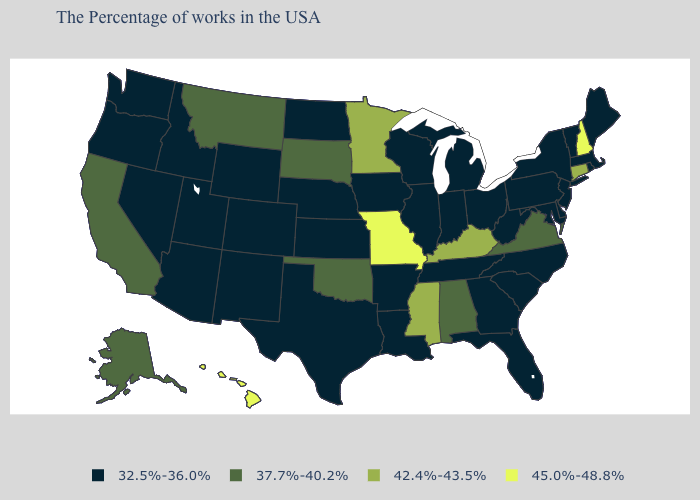What is the highest value in the USA?
Be succinct. 45.0%-48.8%. Name the states that have a value in the range 42.4%-43.5%?
Give a very brief answer. Connecticut, Kentucky, Mississippi, Minnesota. What is the value of New Mexico?
Give a very brief answer. 32.5%-36.0%. What is the value of Louisiana?
Answer briefly. 32.5%-36.0%. Does Wyoming have the lowest value in the USA?
Short answer required. Yes. What is the highest value in the Northeast ?
Write a very short answer. 45.0%-48.8%. What is the highest value in the South ?
Keep it brief. 42.4%-43.5%. What is the highest value in the MidWest ?
Short answer required. 45.0%-48.8%. Does the first symbol in the legend represent the smallest category?
Quick response, please. Yes. Among the states that border Minnesota , does South Dakota have the lowest value?
Keep it brief. No. Which states have the highest value in the USA?
Be succinct. New Hampshire, Missouri, Hawaii. Does Georgia have the highest value in the USA?
Keep it brief. No. Name the states that have a value in the range 32.5%-36.0%?
Concise answer only. Maine, Massachusetts, Rhode Island, Vermont, New York, New Jersey, Delaware, Maryland, Pennsylvania, North Carolina, South Carolina, West Virginia, Ohio, Florida, Georgia, Michigan, Indiana, Tennessee, Wisconsin, Illinois, Louisiana, Arkansas, Iowa, Kansas, Nebraska, Texas, North Dakota, Wyoming, Colorado, New Mexico, Utah, Arizona, Idaho, Nevada, Washington, Oregon. Does New Hampshire have the highest value in the Northeast?
Quick response, please. Yes. Name the states that have a value in the range 42.4%-43.5%?
Answer briefly. Connecticut, Kentucky, Mississippi, Minnesota. 